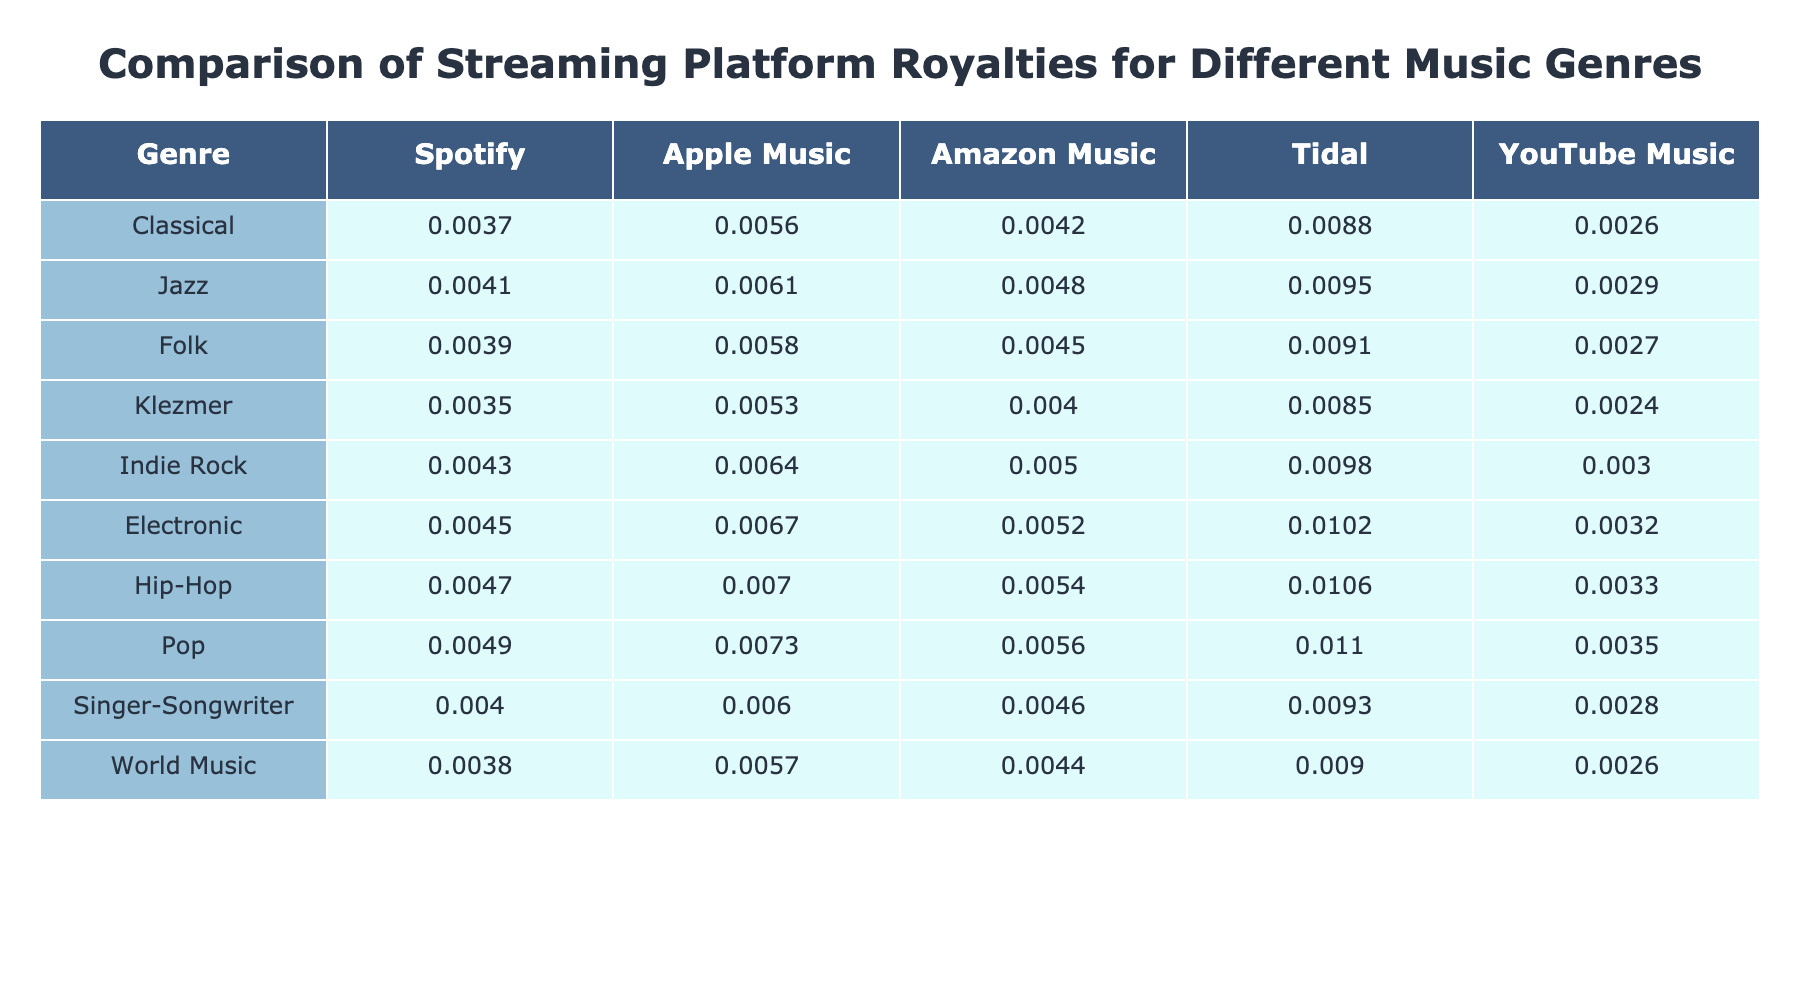What is the royalty rate for Klezmer music on Spotify? According to the table, the royalty rate for Klezmer music on Spotify is 0.0035. This value can be directly found in the row labeled "Klezmer" under the column "Spotify".
Answer: 0.0035 Which streaming platform offers the highest royalty rate for Pop music? The table shows that the highest royalty rate for Pop music is on Tidal, with a value of 0.0110. This can be identified by looking for the highest figure in the "Pop" row.
Answer: Tidal What is the average royalty rate for Jazz across all streaming platforms? To find the average, first sum the royalty rates for Jazz on each platform: 0.0041 + 0.0061 + 0.0048 + 0.0095 + 0.0029 = 0.0274. Then divide by the number of platforms (5): 0.0274 / 5 = 0.00548. Rounding this gives an average of 0.0055.
Answer: 0.0055 Is the royalty rate for Folk music on Apple Music higher than that for Classical music on Spotify? The table shows that the royalty rate for Folk music on Apple Music is 0.0058, while the rate for Classical music on Spotify is 0.0037. Since 0.0058 is greater than 0.0037, the answer is yes.
Answer: Yes What is the difference in royalty rates between Indie Rock on Tidal and Electronic on YouTube Music? The royalty rate for Indie Rock on Tidal is 0.0098, and for Electronic on YouTube Music, it is 0.0032. Subtracting these values: 0.0098 - 0.0032 = 0.0066. Thus, the difference is 0.0066.
Answer: 0.0066 Which genre has the lowest overall royalty rate across all platforms? To determine this, we need to find the lowest individual royalty rate for each genre across all platforms. By comparing the values for each genre, Klezmer has the lowest rate of 0.0024 on YouTube Music, making it the genre with the lowest overall royalty rate.
Answer: Klezmer Does Amazon Music pay more for Indie Rock than it does for Jazz? Looking at the table, the royalty rate for Indie Rock on Amazon Music is 0.0050, while for Jazz, it is 0.0048. Since 0.0050 is greater than 0.0048, the answer is yes.
Answer: Yes What is the total royalty rate for Classical music across all platforms? To find the total, sum the royalty rates for Classical across all platforms: 0.0037 + 0.0056 + 0.0042 + 0.0088 + 0.0026 = 0.0259. Hence, the total royalty rate for Classical music is 0.0259.
Answer: 0.0259 